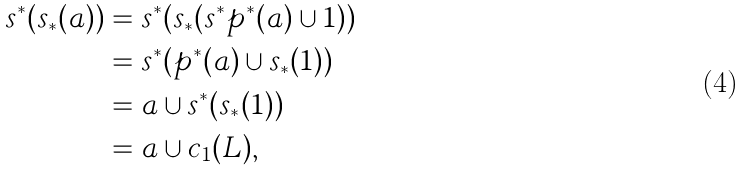Convert formula to latex. <formula><loc_0><loc_0><loc_500><loc_500>s ^ { * } ( s _ { * } ( a ) ) & = s ^ { * } ( s _ { * } ( s ^ { * } p ^ { * } ( a ) \cup 1 ) ) \\ & = s ^ { * } ( p ^ { * } ( a ) \cup s _ { * } ( 1 ) ) \\ & = a \cup s ^ { * } ( s _ { * } ( 1 ) ) \\ & = a \cup c _ { 1 } ( L ) ,</formula> 